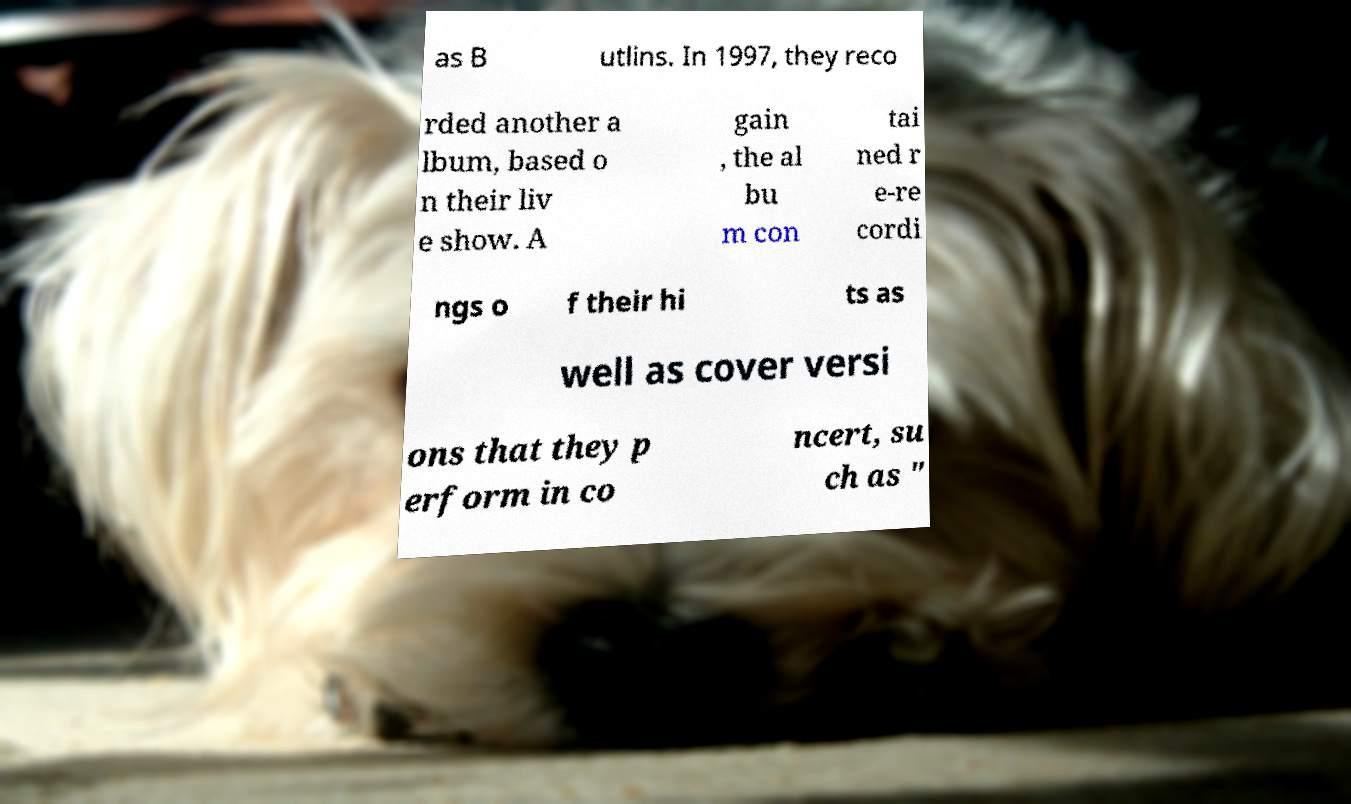What messages or text are displayed in this image? I need them in a readable, typed format. as B utlins. In 1997, they reco rded another a lbum, based o n their liv e show. A gain , the al bu m con tai ned r e-re cordi ngs o f their hi ts as well as cover versi ons that they p erform in co ncert, su ch as " 